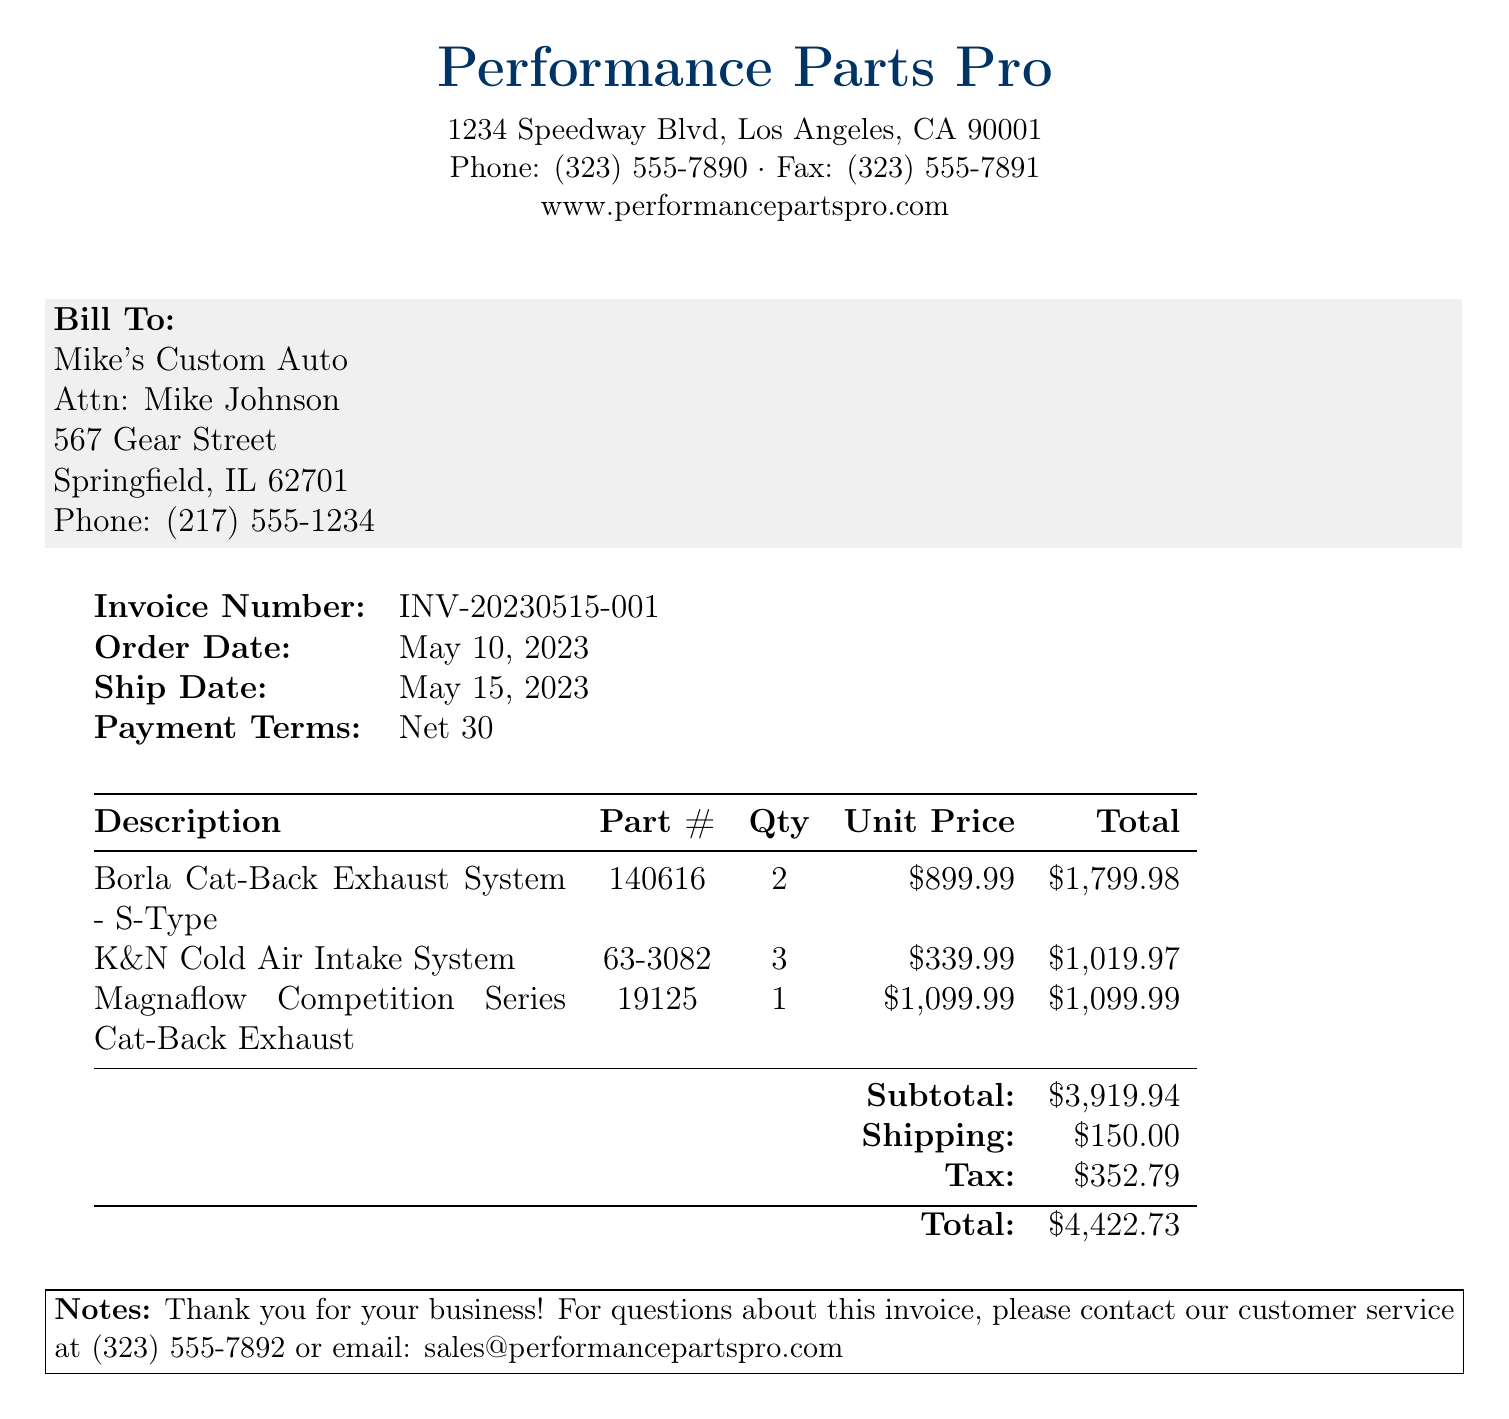what is the invoice number? The invoice number is specifically labeled on the document under "Invoice Number."
Answer: INV-20230515-001 what is the total amount due? The total amount due is clearly stated in the table under "Total."
Answer: $4,422.73 who is the bill recipient? The bill recipient information is located in the "Bill To" section of the document.
Answer: Mike's Custom Auto what is the payment term? The document specifies payment terms directly in the invoice information section.
Answer: Net 30 how many cold air intake systems were ordered? The quantity of cold air intake systems can be found next to its description in the table.
Answer: 3 what is the subtotal before shipping and tax? The subtotal is listed in the invoice table as a separate line before shipping and tax.
Answer: $3,919.94 when was the order date? The order date is mentioned in the invoice information section.
Answer: May 10, 2023 what is the shipping cost? The shipping cost is provided in the totals section of the invoice.
Answer: $150.00 how many types of exhaust systems are listed? The types of exhaust systems are included in the description column of the table.
Answer: 2 